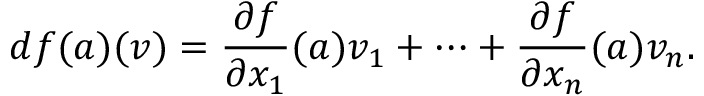<formula> <loc_0><loc_0><loc_500><loc_500>d f ( { a } ) ( { v } ) = { \frac { \partial f } { \partial x _ { 1 } } } ( { a } ) v _ { 1 } + \cdots + { \frac { \partial f } { \partial x _ { n } } } ( { a } ) v _ { n } .</formula> 